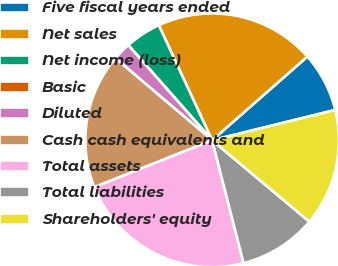Convert chart. <chart><loc_0><loc_0><loc_500><loc_500><pie_chart><fcel>Five fiscal years ended<fcel>Net sales<fcel>Net income (loss)<fcel>Basic<fcel>Diluted<fcel>Cash cash equivalents and<fcel>Total assets<fcel>Total liabilities<fcel>Shareholders' equity<nl><fcel>7.63%<fcel>20.44%<fcel>4.59%<fcel>0.0%<fcel>2.3%<fcel>17.24%<fcel>22.95%<fcel>9.92%<fcel>14.94%<nl></chart> 